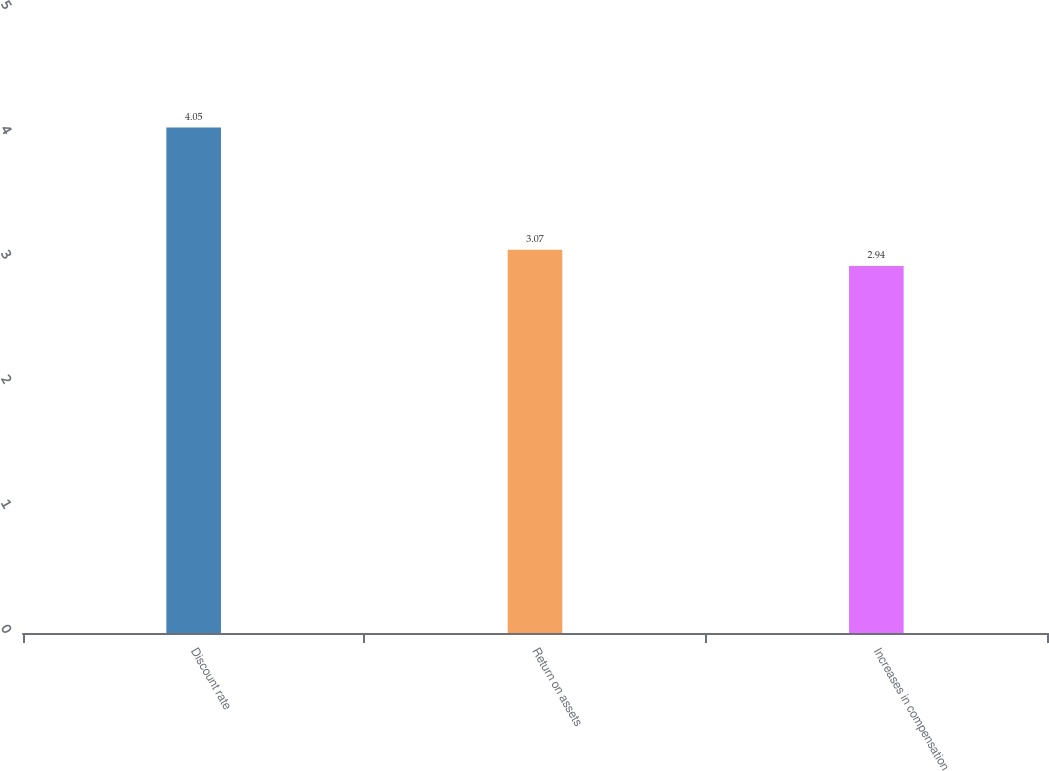Convert chart to OTSL. <chart><loc_0><loc_0><loc_500><loc_500><bar_chart><fcel>Discount rate<fcel>Return on assets<fcel>Increases in compensation<nl><fcel>4.05<fcel>3.07<fcel>2.94<nl></chart> 